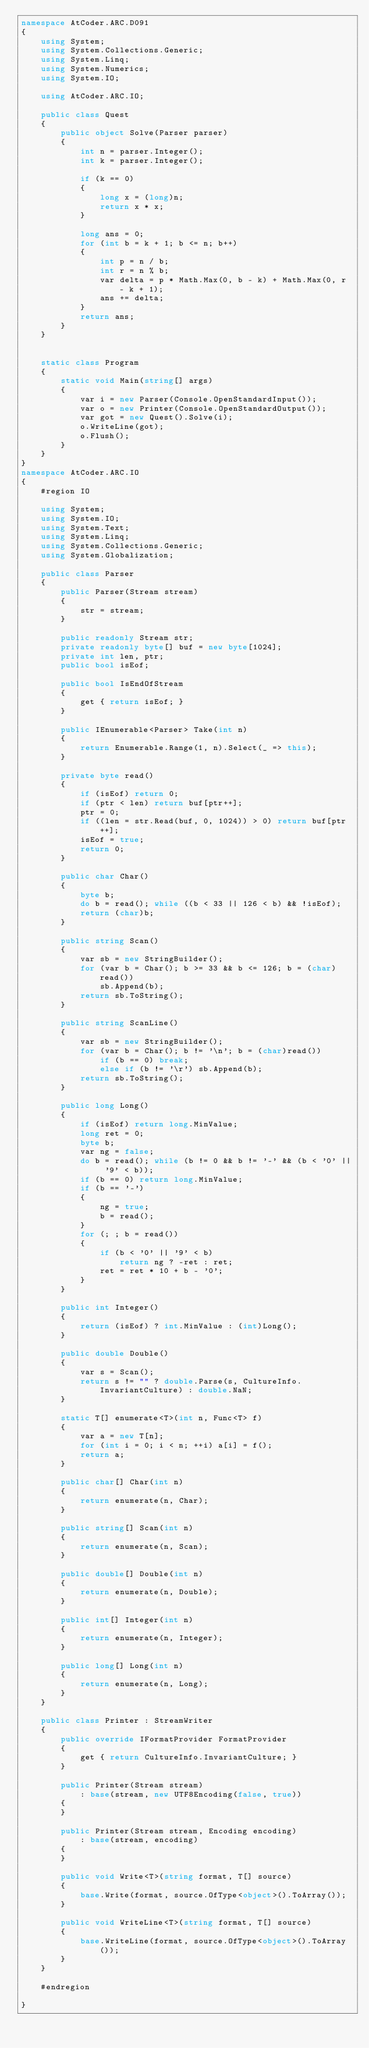<code> <loc_0><loc_0><loc_500><loc_500><_C#_>namespace AtCoder.ARC.D091
{
    using System;
    using System.Collections.Generic;
    using System.Linq;
    using System.Numerics;
    using System.IO;

    using AtCoder.ARC.IO;

    public class Quest
    {
        public object Solve(Parser parser)
        {
            int n = parser.Integer();
            int k = parser.Integer();

            if (k == 0)
            {
                long x = (long)n;
                return x * x;
            }

            long ans = 0;
            for (int b = k + 1; b <= n; b++)
            {
                int p = n / b;
                int r = n % b;
                var delta = p * Math.Max(0, b - k) + Math.Max(0, r - k + 1);
                ans += delta;
            }
            return ans;
        }
    }


    static class Program
    {
        static void Main(string[] args)
        {
            var i = new Parser(Console.OpenStandardInput());
            var o = new Printer(Console.OpenStandardOutput());
            var got = new Quest().Solve(i);
            o.WriteLine(got);
            o.Flush();
        }
    }
}
namespace AtCoder.ARC.IO
{
    #region IO

    using System;
    using System.IO;
    using System.Text;
    using System.Linq;
    using System.Collections.Generic;
    using System.Globalization;

    public class Parser
    {
        public Parser(Stream stream)
        {
            str = stream;
        }

        public readonly Stream str;
        private readonly byte[] buf = new byte[1024];
        private int len, ptr;
        public bool isEof;

        public bool IsEndOfStream
        {
            get { return isEof; }
        }

        public IEnumerable<Parser> Take(int n)
        {
            return Enumerable.Range(1, n).Select(_ => this);
        }

        private byte read()
        {
            if (isEof) return 0;
            if (ptr < len) return buf[ptr++];
            ptr = 0;
            if ((len = str.Read(buf, 0, 1024)) > 0) return buf[ptr++];
            isEof = true;
            return 0;
        }

        public char Char()
        {
            byte b;
            do b = read(); while ((b < 33 || 126 < b) && !isEof);
            return (char)b;
        }

        public string Scan()
        {
            var sb = new StringBuilder();
            for (var b = Char(); b >= 33 && b <= 126; b = (char)read())
                sb.Append(b);
            return sb.ToString();
        }

        public string ScanLine()
        {
            var sb = new StringBuilder();
            for (var b = Char(); b != '\n'; b = (char)read())
                if (b == 0) break;
                else if (b != '\r') sb.Append(b);
            return sb.ToString();
        }

        public long Long()
        {
            if (isEof) return long.MinValue;
            long ret = 0;
            byte b;
            var ng = false;
            do b = read(); while (b != 0 && b != '-' && (b < '0' || '9' < b));
            if (b == 0) return long.MinValue;
            if (b == '-')
            {
                ng = true;
                b = read();
            }
            for (; ; b = read())
            {
                if (b < '0' || '9' < b)
                    return ng ? -ret : ret;
                ret = ret * 10 + b - '0';
            }
        }

        public int Integer()
        {
            return (isEof) ? int.MinValue : (int)Long();
        }

        public double Double()
        {
            var s = Scan();
            return s != "" ? double.Parse(s, CultureInfo.InvariantCulture) : double.NaN;
        }

        static T[] enumerate<T>(int n, Func<T> f)
        {
            var a = new T[n];
            for (int i = 0; i < n; ++i) a[i] = f();
            return a;
        }

        public char[] Char(int n)
        {
            return enumerate(n, Char);
        }

        public string[] Scan(int n)
        {
            return enumerate(n, Scan);
        }

        public double[] Double(int n)
        {
            return enumerate(n, Double);
        }

        public int[] Integer(int n)
        {
            return enumerate(n, Integer);
        }

        public long[] Long(int n)
        {
            return enumerate(n, Long);
        }
    }

    public class Printer : StreamWriter
    {
        public override IFormatProvider FormatProvider
        {
            get { return CultureInfo.InvariantCulture; }
        }

        public Printer(Stream stream)
            : base(stream, new UTF8Encoding(false, true))
        {
        }

        public Printer(Stream stream, Encoding encoding)
            : base(stream, encoding)
        {
        }

        public void Write<T>(string format, T[] source)
        {
            base.Write(format, source.OfType<object>().ToArray());
        }

        public void WriteLine<T>(string format, T[] source)
        {
            base.WriteLine(format, source.OfType<object>().ToArray());
        }
    }

    #endregion

}</code> 